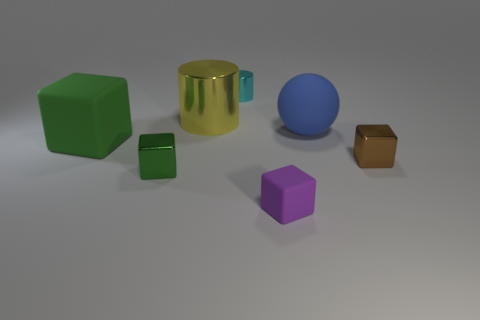What is the material of the tiny cube on the right side of the matte cube right of the small cyan cylinder?
Provide a succinct answer. Metal. What number of tiny objects are either red shiny blocks or blue rubber things?
Provide a succinct answer. 0. The cyan object has what size?
Make the answer very short. Small. Is the number of big blue objects left of the big metal object greater than the number of brown shiny things?
Make the answer very short. No. Are there the same number of metallic blocks behind the blue object and tiny brown metallic things that are on the left side of the tiny green cube?
Provide a short and direct response. Yes. What is the color of the metal thing that is on the left side of the cyan object and in front of the blue rubber sphere?
Offer a very short reply. Green. Is there any other thing that is the same size as the rubber ball?
Your response must be concise. Yes. Are there more tiny cyan shiny objects in front of the large green matte block than big green cubes that are on the right side of the large yellow metal thing?
Keep it short and to the point. No. There is a metal block to the right of the ball; is it the same size as the small matte block?
Your answer should be very brief. Yes. How many rubber things are behind the matte cube that is on the left side of the yellow cylinder that is to the left of the large ball?
Provide a succinct answer. 1. 